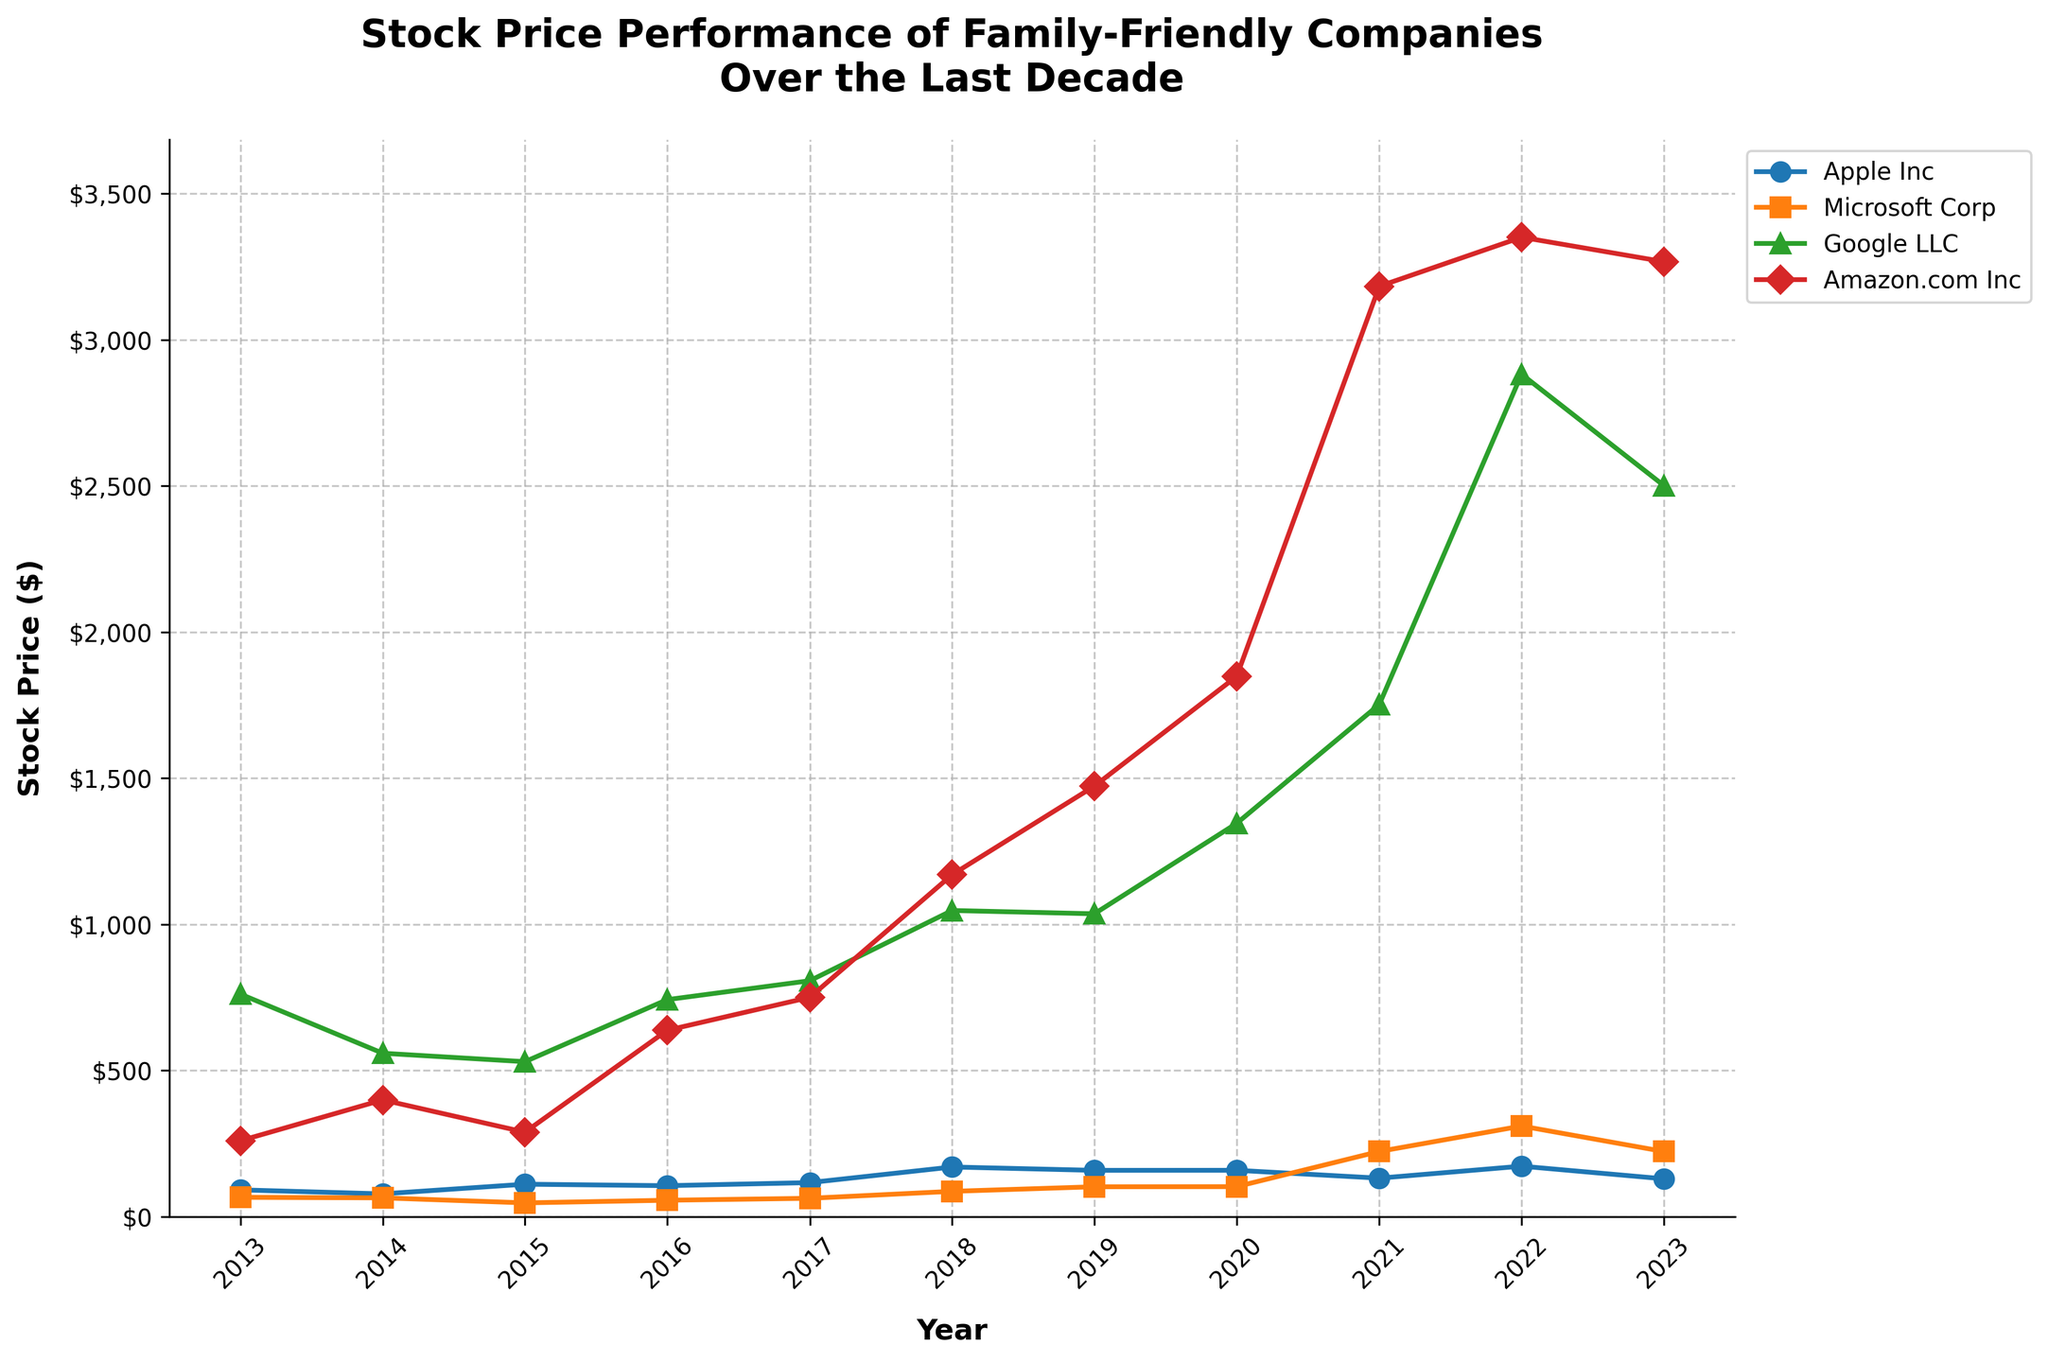1. What is the title of the plot? The title is present at the top of the plot, in bold text.
Answer: Stock Price Performance of Family-Friendly Companies Over the Last Decade 2. Which company had the highest stock price in 2022? By looking at the 2022 data points, the highest price is indicated by the line reaching the highest point on the y-axis. Google LLC had the highest stock price.
Answer: Google LLC 3. Which company saw the largest increase in stock price from 2021 to 2022? Comparing data points for 2021 and 2022 for each company, calculate the difference: Apple Inc (172.01 - 131.01 = 41), Microsoft Corp (309.41 - 222.42 = 86.99), Google LLC (2881.91 - 1751.88 = 1130.03), Amazon.com Inc (3350.55 - 3182.70 = 167.85). Google LLC has the largest increase.
Answer: Google LLC 4. How does Microsoft's stock price in 2023 compare to its stock price in 2021? Check the data points for Microsoft in 2021 and 2023 and compare the values. In 2021, it was 222.42 and in 2023, it is 222.22.
Answer: Slightly lower in 2023 5. What trends can be observed in Apple's stock price over the decade? Observing the line for Apple Inc from 2013 to 2023, the stock price fluctuates, initially increases, peaks around 2018, declines slightly, then increases again, peaking in 2022, and then dropping in 2023.
Answer: Fluctuating with a peak in 2022 6. Which company has the most stable stock price trend over the decade? By comparing the overall trends of the lines, Microsoft's stock price shows more consistent upward trends with fewer drastic fluctuations compared to the others.
Answer: Microsoft Corp 7. What was the approximate stock price of Amazon.com Inc in 2016? Find the data point for Amazon.com Inc in 2016 on the plot by following the vertical line from the x-axis labeled 2016.
Answer: Approximately $636.99 8. How much did the stock price of Google LLC increase from 2013 to 2023? Subtract the 2013 stock price of Google LLC from its 2023 stock price: 2500.89 - 760.69 = 1740.20.
Answer: $1740.20 9. From the information provided, which company experienced the largest overall growth in stock price from 2014 to 2023? Examine the stock prices of each company in 2014 and compare them to 2023; Apple Inc (128.79 - 77.28 = 51.51), Microsoft Corp (222.22 - 63.59 = 158.63), Google LLC (2500.89 - 558.46 = 1942.43), Amazon.com Inc (3266.89 - 398.79 = 2868.10). Amazon.com Inc shows the largest growth.
Answer: Amazon.com Inc 